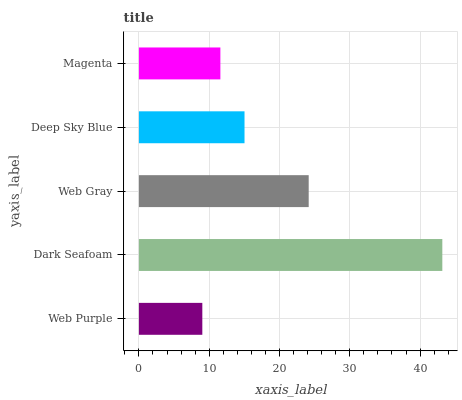Is Web Purple the minimum?
Answer yes or no. Yes. Is Dark Seafoam the maximum?
Answer yes or no. Yes. Is Web Gray the minimum?
Answer yes or no. No. Is Web Gray the maximum?
Answer yes or no. No. Is Dark Seafoam greater than Web Gray?
Answer yes or no. Yes. Is Web Gray less than Dark Seafoam?
Answer yes or no. Yes. Is Web Gray greater than Dark Seafoam?
Answer yes or no. No. Is Dark Seafoam less than Web Gray?
Answer yes or no. No. Is Deep Sky Blue the high median?
Answer yes or no. Yes. Is Deep Sky Blue the low median?
Answer yes or no. Yes. Is Web Gray the high median?
Answer yes or no. No. Is Dark Seafoam the low median?
Answer yes or no. No. 